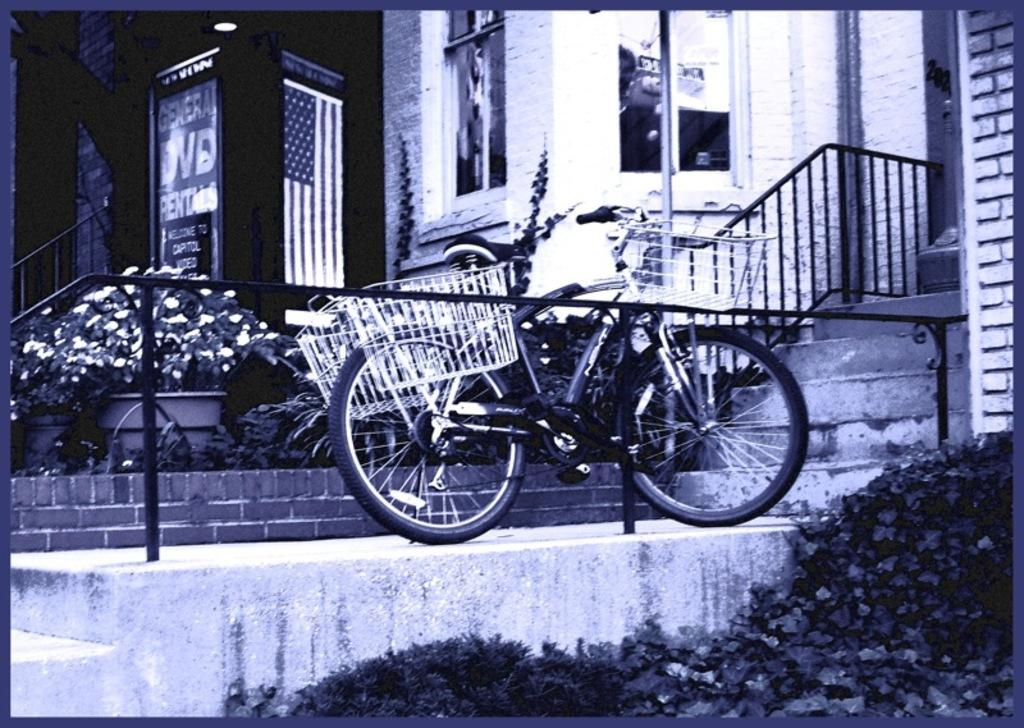What is the color scheme of the image? The image is black and white. What type of structure can be seen in the image? There is a building in the image. What is attached to the building? There are posters on the building. What architectural feature is present in the image? There are stairs in the image. What safety feature is included in the image? There is railing in the image. What objects are present in the image that are used for support or guidance? There are poles in the image. What mode of transportation is visible in the image? There is a bicycle in the image. What type of vegetation is present in the image? There are plants in the image. What type of container is present in the image? There is a pot in the image. What type of decorative element is present in the image? There are flowers in the image. What type of posters are present in the image? There are posters with text and images in the image. What type of army uniform is the grandmother wearing in the image? There is no grandmother or army uniform present in the image. What color is the sky in the image? The image is black and white, so it does not depict a colored sky. 